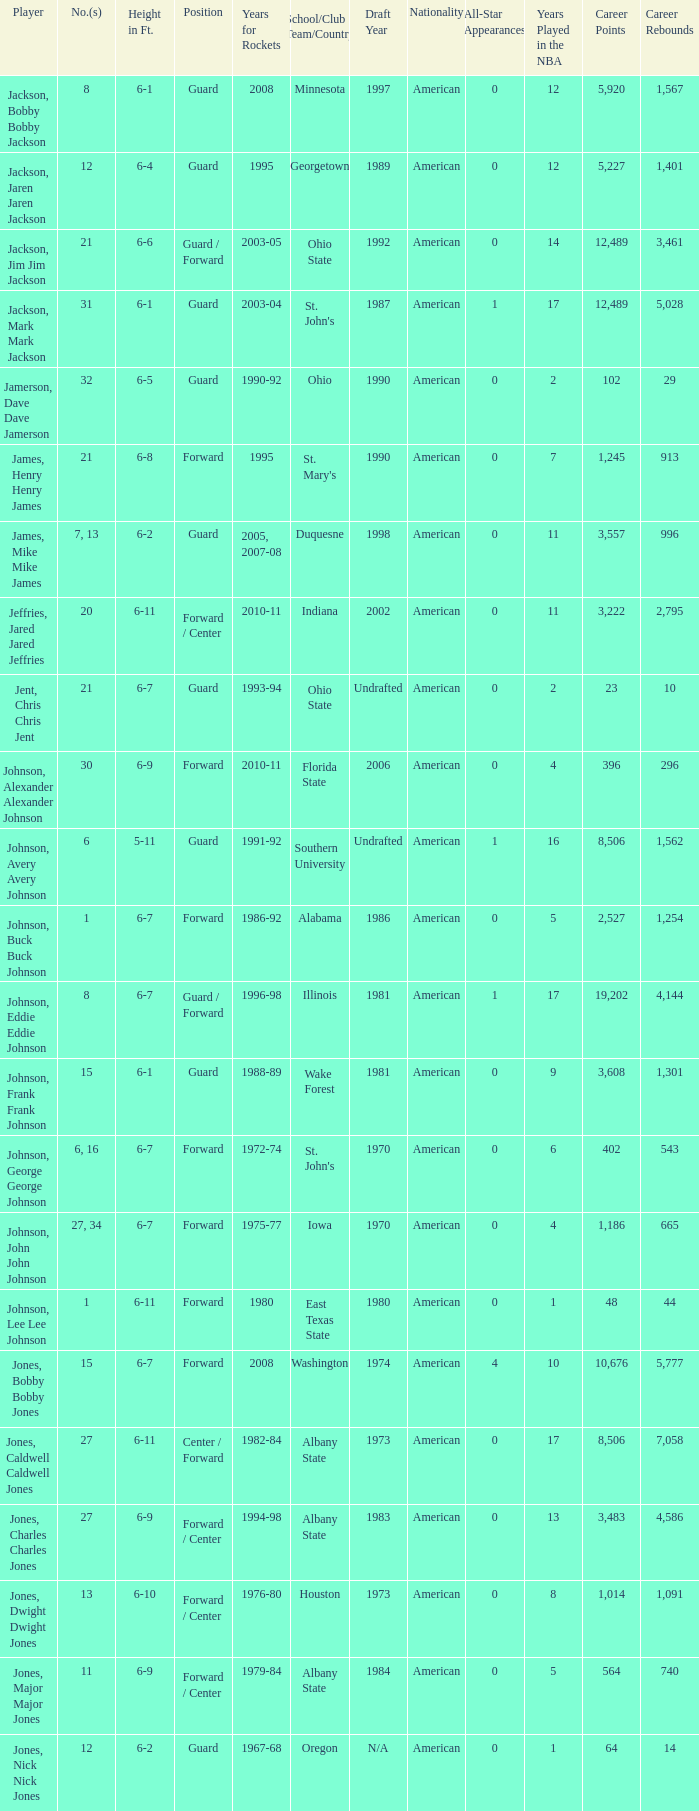How tall is the player jones, major major jones? 6-9. 